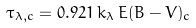Convert formula to latex. <formula><loc_0><loc_0><loc_500><loc_500>\tau _ { \lambda , c } = 0 . 9 2 1 \, k _ { \lambda } \, E ( B - V ) _ { c }</formula> 